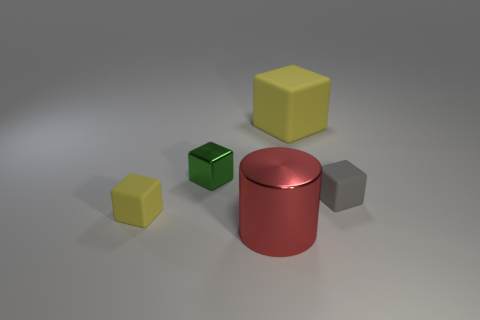Do the tiny thing to the right of the red cylinder and the tiny green object have the same material?
Your answer should be compact. No. What is the material of the large yellow block?
Give a very brief answer. Rubber. There is a tiny yellow matte block; are there any big metallic cylinders behind it?
Offer a terse response. No. Is the material of the cylinder on the right side of the small metallic cube the same as the object to the right of the big yellow object?
Offer a very short reply. No. What number of red metallic objects have the same size as the gray rubber cube?
Your answer should be compact. 0. The small rubber thing that is the same color as the big block is what shape?
Offer a very short reply. Cube. There is a big object behind the large cylinder; what is its material?
Keep it short and to the point. Rubber. How many large yellow matte things are the same shape as the tiny green object?
Your answer should be compact. 1. There is a green object that is made of the same material as the cylinder; what is its shape?
Your answer should be very brief. Cube. What is the shape of the yellow object that is behind the tiny rubber block on the left side of the yellow object that is right of the red object?
Make the answer very short. Cube. 